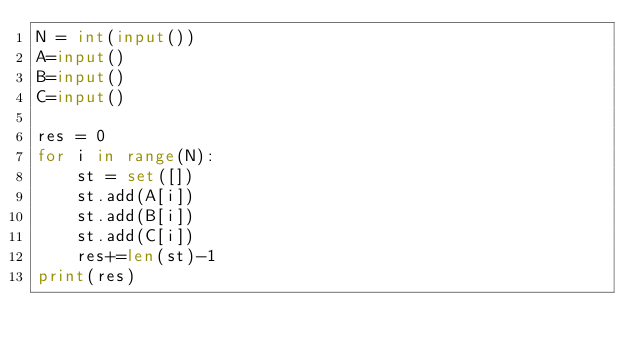<code> <loc_0><loc_0><loc_500><loc_500><_Python_>N = int(input())
A=input()
B=input()
C=input()

res = 0
for i in range(N):
    st = set([])
    st.add(A[i])
    st.add(B[i])
    st.add(C[i])
    res+=len(st)-1
print(res)
</code> 